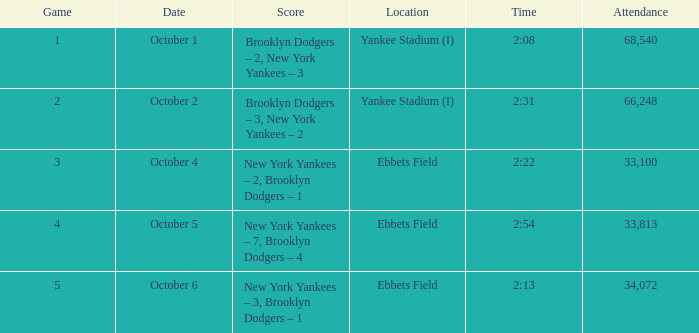How many people were present at 2:13? 34072.0. 